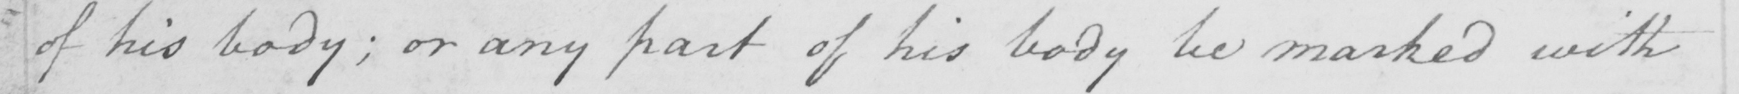What does this handwritten line say? of his body; or any part of his body be marked with 